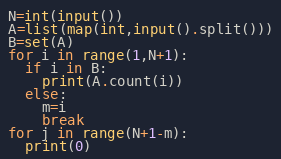Convert code to text. <code><loc_0><loc_0><loc_500><loc_500><_Python_>N=int(input())
A=list(map(int,input().split()))
B=set(A)
for i in range(1,N+1):
  if i in B:
    print(A.count(i))
  else:
    m=i
    break
for j in range(N+1-m):
  print(0)</code> 